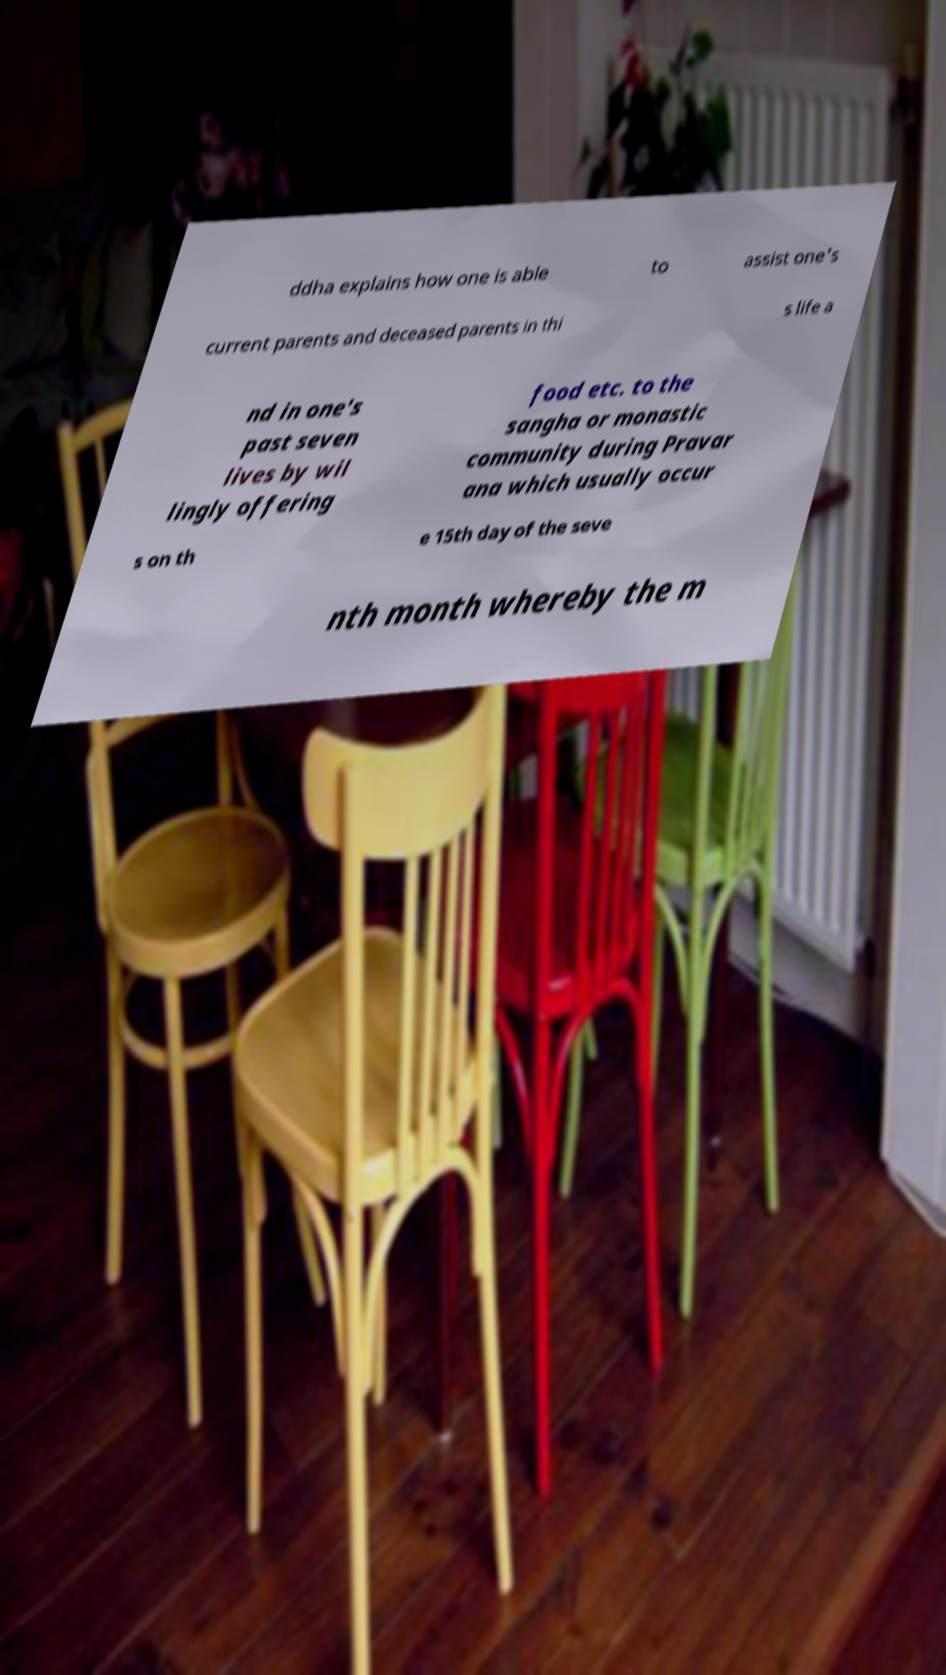What messages or text are displayed in this image? I need them in a readable, typed format. ddha explains how one is able to assist one's current parents and deceased parents in thi s life a nd in one's past seven lives by wil lingly offering food etc. to the sangha or monastic community during Pravar ana which usually occur s on th e 15th day of the seve nth month whereby the m 